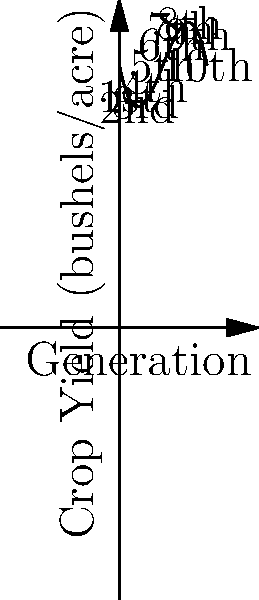The Thompson family has been managing their wheat farm for ten generations. The graph shows the crop yield (in bushels per acre) for each generation. Which generation achieved the highest crop yield, and what factors might have contributed to the changes in yield over time? To solve this problem, we need to analyze the polynomial curve representing crop yield across generations:

1. Observe the curve: The graph shows a polynomial function that increases, reaches a peak, and then decreases.

2. Identify the highest point: The curve reaches its maximum around the 6th or 7th generation.

3. Determine the exact peak: The 6th generation appears to have the highest yield.

4. Factors contributing to changes:
   a) Initial increase (1st to 6th generation):
      - Improved farming techniques passed down through generations
      - Better seed selection and crop rotation practices
      - Introduction of basic machinery and fertilizers
   
   b) Decline after 6th generation:
      - Possible soil depletion due to intensive farming
      - Changes in local climate conditions
      - Shift away from traditional farming methods

5. Cultural context: The initial rise in crop yield aligns with traditional values of hard work and generational knowledge. The later decline might be attributed to modern influences moving away from time-tested farming practices.
Answer: 6th generation; factors include improved traditional techniques and later soil depletion. 